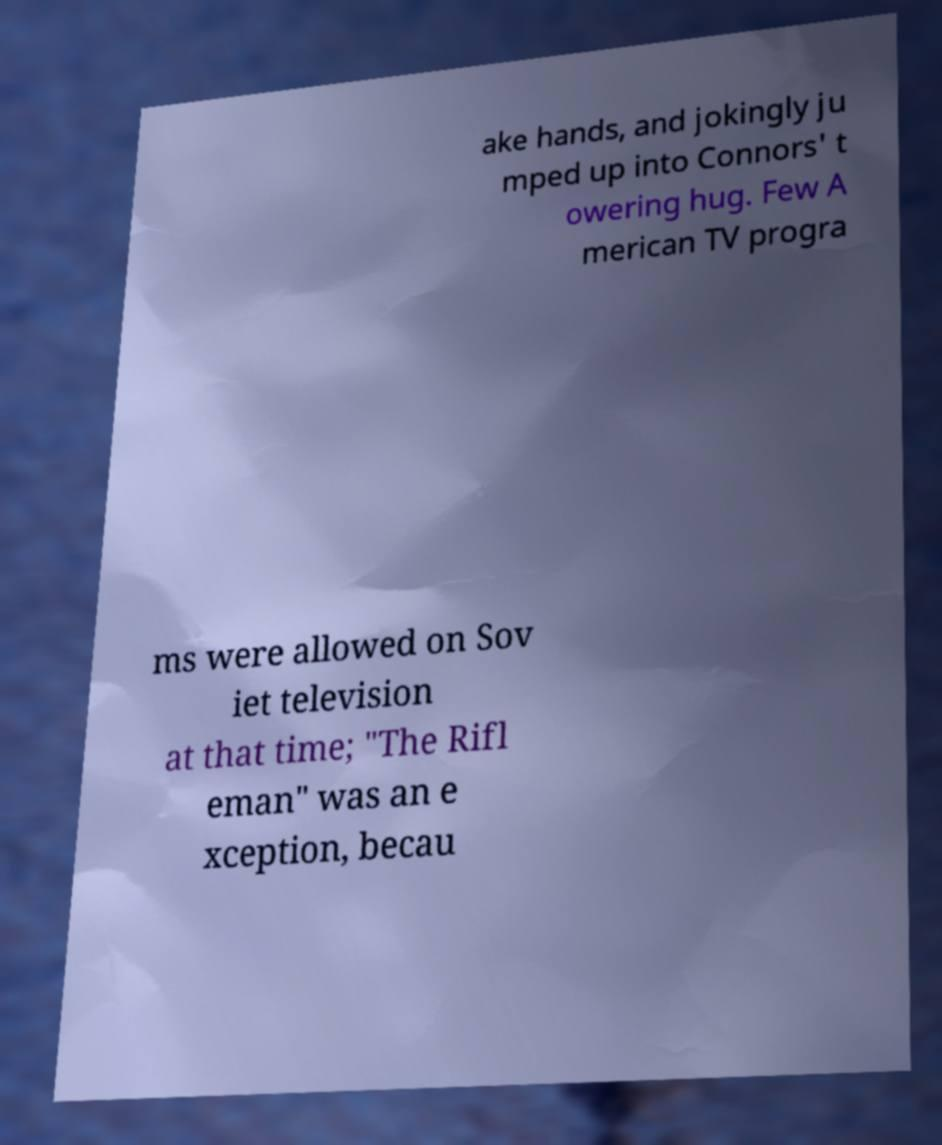For documentation purposes, I need the text within this image transcribed. Could you provide that? ake hands, and jokingly ju mped up into Connors' t owering hug. Few A merican TV progra ms were allowed on Sov iet television at that time; "The Rifl eman" was an e xception, becau 